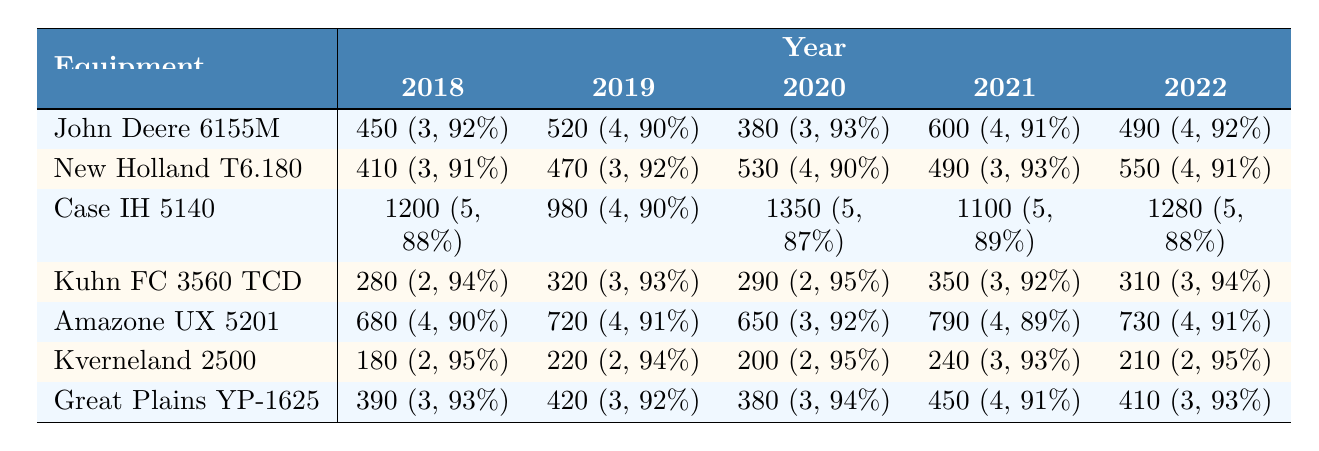What was the highest maintenance cost recorded for any piece of equipment in 2020? The maintenance costs for each piece of equipment in 2020 are: John Deere 6155M - 380, New Holland T6.180 - 530, Case IH 5140 - 1350, Kuhn FC 3560 TCD - 290, Amazone UX 5201 - 650, Kverneland 2500 - 200, and Great Plains YP-1625 - 380. The highest among these is 1350 for the Case IH 5140 Combine Harvester.
Answer: 1350 Which equipment had the lowest average safety check rating across all years? The safety check ratings for each piece of equipment are: John Deere 6155M - 3.6, New Holland T6.180 - 3.4, Case IH 5140 - 5, Kuhn FC 3560 TCD - 2.6, Amazone UX 5201 - 3.6, Kverneland 2500 - 2.2, and Great Plains YP-1625 - 3.2. The lowest average is for Kverneland 2500 at 2.2.
Answer: Kverneland 2500 How much did maintenance for the Great Plains YP-1625 Planter increase from 2018 to 2022? The maintenance costs for Great Plains YP-1625 Planter over the years are: 390 (2018), 420 (2019), 380 (2020), 450 (2021), and 410 (2022). The increase from 2018 (390) to 2022 (410) is 410 - 390 = 20.
Answer: 20 Did the Amazone UX 5201 Super Sprayer have a consistent efficiency rating from 2018 to 2022? The efficiency ratings for Amazone UX 5201 are: 90 (2018), 91 (2019), 92 (2020), 89 (2021), and 91 (2022). These numbers show some fluctuations, particularly a drop in 2021, thus it was not consistent.
Answer: No What is the average maintenance cost for all equipment in 2021, and how does it compare to the average in 2020? The maintenance costs for 2021 are: John Deere 6155M - 600, New Holland T6.180 - 490, Case IH 5140 - 1100, Kuhn FC 3560 TCD - 350, Amazone UX 5201 - 790, Kverneland 2500 - 240, Great Plains YP-1625 - 450. Their sum is 600 + 490 + 1100 + 350 + 790 + 240 + 450 = 3020; the average is 3020 / 7 ≈ 431.43. For 2020, the average was 380 + 530 + 1350 + 290 + 650 + 200 + 380 = 3180; average = 3180 / 7 ≈ 454.29. The average maintenance cost in 2021 is lower than that in 2020.
Answer: Lower Which equipment had the most significant maintenance cost reduction from 2019 to 2020? The maintenance costs from 2019 to 2020 for each piece of equipment are: John Deere 6155M - 140 reduction (520 to 380), New Holland T6.180 - 60 (470 to 530), Case IH 5140 - 370 (980 to 1350), Kuhn FC 3560 TCD - 30 (320 to 290), Amazone UX 5201 - 70 (720 to 650), Kverneland 2500 - 20 (220 to 200), Great Plains YP-1625 - 40 (420 to 380). The largest reduction is 140 for the John Deere 6155M Tractor.
Answer: John Deere 6155M 